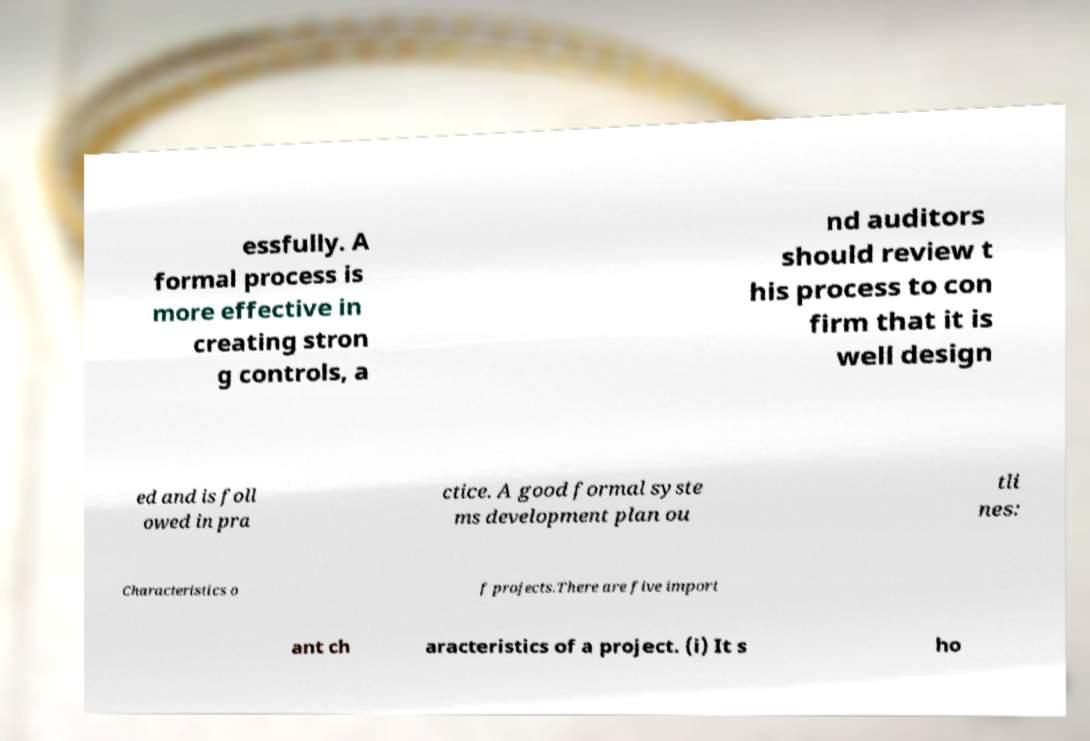Please read and relay the text visible in this image. What does it say? essfully. A formal process is more effective in creating stron g controls, a nd auditors should review t his process to con firm that it is well design ed and is foll owed in pra ctice. A good formal syste ms development plan ou tli nes: Characteristics o f projects.There are five import ant ch aracteristics of a project. (i) It s ho 